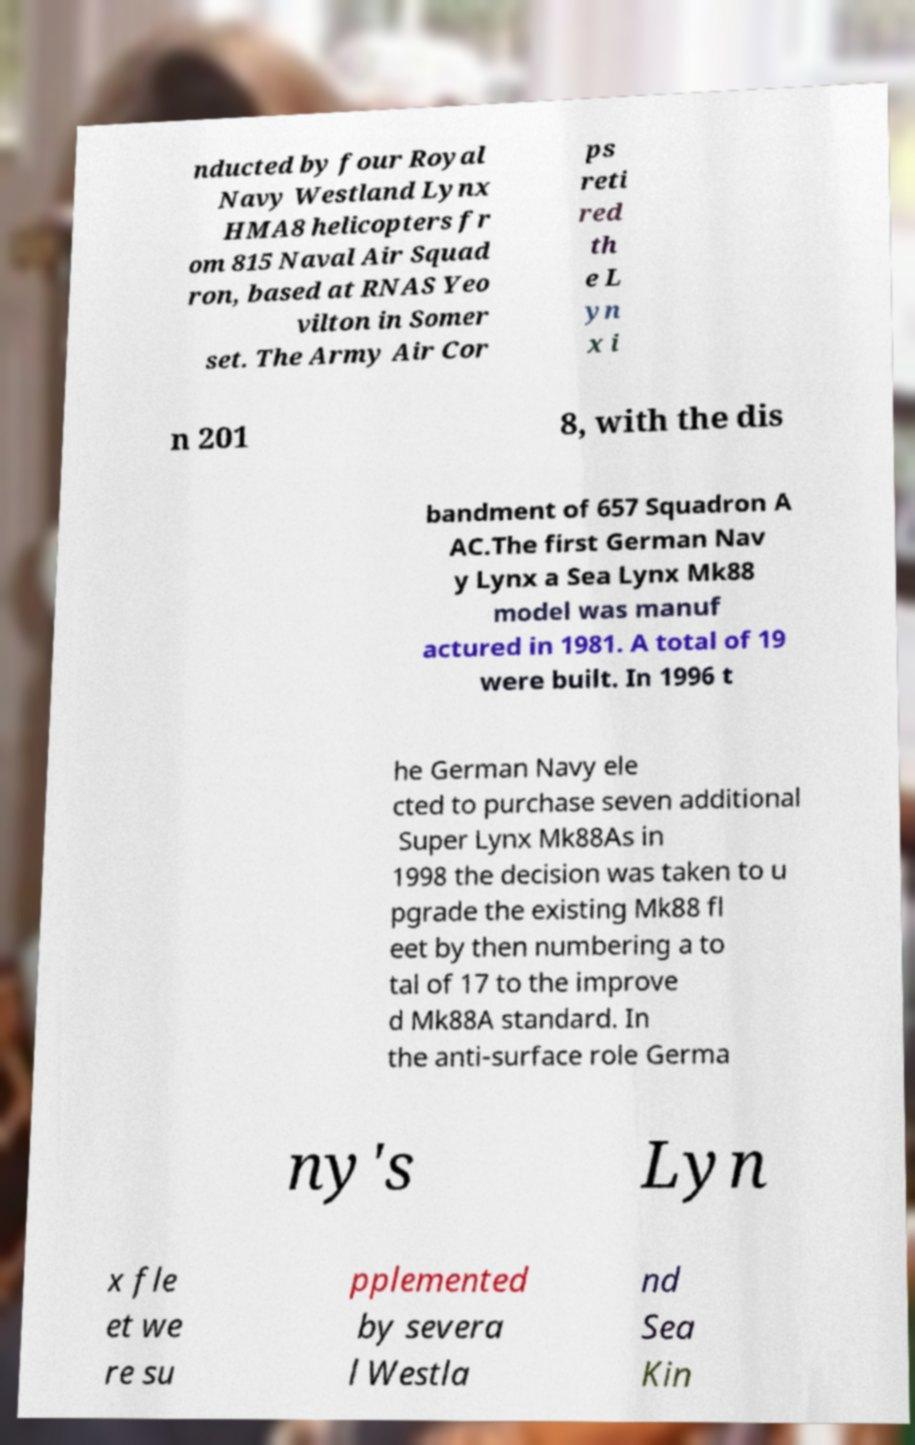I need the written content from this picture converted into text. Can you do that? nducted by four Royal Navy Westland Lynx HMA8 helicopters fr om 815 Naval Air Squad ron, based at RNAS Yeo vilton in Somer set. The Army Air Cor ps reti red th e L yn x i n 201 8, with the dis bandment of 657 Squadron A AC.The first German Nav y Lynx a Sea Lynx Mk88 model was manuf actured in 1981. A total of 19 were built. In 1996 t he German Navy ele cted to purchase seven additional Super Lynx Mk88As in 1998 the decision was taken to u pgrade the existing Mk88 fl eet by then numbering a to tal of 17 to the improve d Mk88A standard. In the anti-surface role Germa ny's Lyn x fle et we re su pplemented by severa l Westla nd Sea Kin 